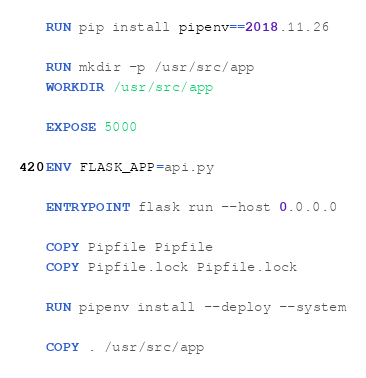Convert code to text. <code><loc_0><loc_0><loc_500><loc_500><_Dockerfile_>RUN pip install pipenv==2018.11.26

RUN mkdir -p /usr/src/app
WORKDIR /usr/src/app

EXPOSE 5000

ENV FLASK_APP=api.py

ENTRYPOINT flask run --host 0.0.0.0

COPY Pipfile Pipfile
COPY Pipfile.lock Pipfile.lock

RUN pipenv install --deploy --system

COPY . /usr/src/app
</code> 